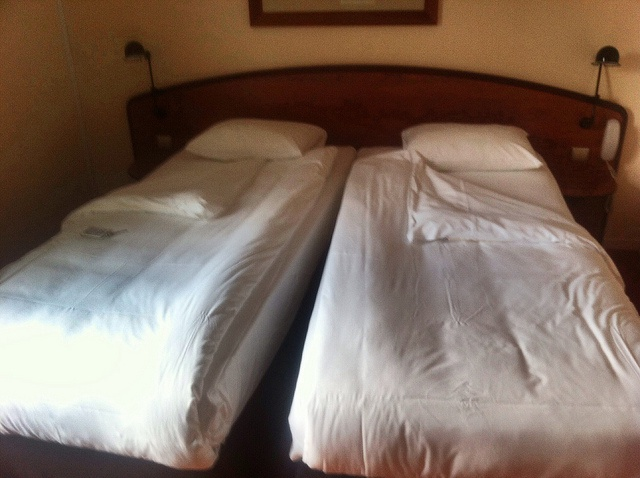Describe the objects in this image and their specific colors. I can see a bed in maroon, darkgray, black, white, and gray tones in this image. 